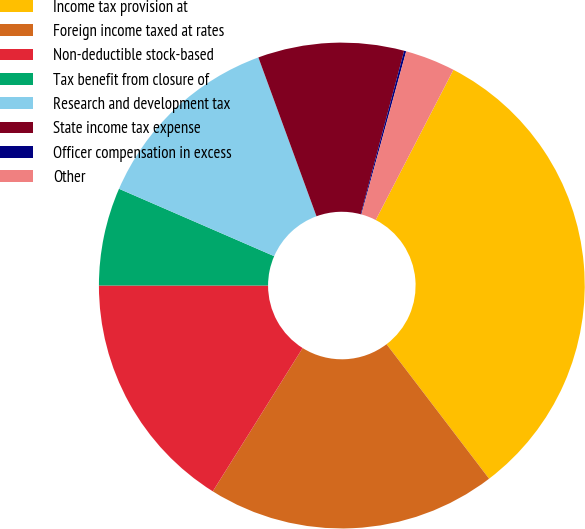Convert chart to OTSL. <chart><loc_0><loc_0><loc_500><loc_500><pie_chart><fcel>Income tax provision at<fcel>Foreign income taxed at rates<fcel>Non-deductible stock-based<fcel>Tax benefit from closure of<fcel>Research and development tax<fcel>State income tax expense<fcel>Officer compensation in excess<fcel>Other<nl><fcel>32.04%<fcel>19.28%<fcel>16.09%<fcel>6.52%<fcel>12.9%<fcel>9.71%<fcel>0.14%<fcel>3.33%<nl></chart> 